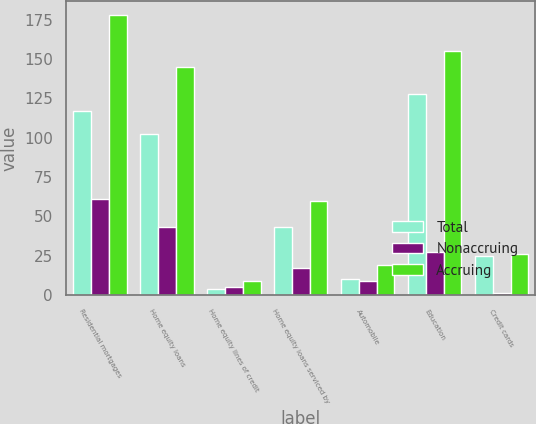<chart> <loc_0><loc_0><loc_500><loc_500><stacked_bar_chart><ecel><fcel>Residential mortgages<fcel>Home equity loans<fcel>Home equity lines of credit<fcel>Home equity loans serviced by<fcel>Automobile<fcel>Education<fcel>Credit cards<nl><fcel>Total<fcel>117<fcel>102<fcel>4<fcel>43<fcel>10<fcel>128<fcel>25<nl><fcel>Nonaccruing<fcel>61<fcel>43<fcel>5<fcel>17<fcel>9<fcel>27<fcel>1<nl><fcel>Accruing<fcel>178<fcel>145<fcel>9<fcel>60<fcel>19<fcel>155<fcel>26<nl></chart> 